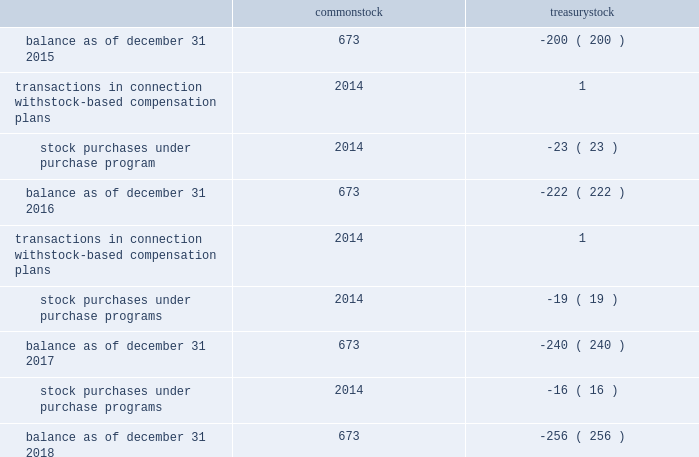Table of contents valero energy corporation notes to consolidated financial statements ( continued ) 11 .
Equity share activity activity in the number of shares of common stock and treasury stock was as follows ( in millions ) : common treasury .
Preferred stock we have 20 million shares of preferred stock authorized with a par value of $ 0.01 per share .
No shares of preferred stock were outstanding as of december 31 , 2018 or 2017 .
Treasury stock we purchase shares of our common stock as authorized under our common stock purchase program ( described below ) and to meet our obligations under employee stock-based compensation plans .
On july 13 , 2015 , our board of directors authorized us to purchase $ 2.5 billion of our outstanding common stock with no expiration date , and we completed that program during 2017 .
On september 21 , 2016 , our board of directors authorized our purchase of up to an additional $ 2.5 billion with no expiration date , and we completed that program during 2018 .
On january 23 , 2018 , our board of directors authorized our purchase of up to an additional $ 2.5 billion ( the 2018 program ) with no expiration date .
During the years ended december 31 , 2018 , 2017 , and 2016 , we purchased $ 1.5 billion , $ 1.3 billion , and $ 1.3 billion , respectively , of our common stock under our programs .
As of december 31 , 2018 , we have approval under the 2018 program to purchase approximately $ 2.2 billion of our common stock .
Common stock dividends on january 24 , 2019 , our board of directors declared a quarterly cash dividend of $ 0.90 per common share payable on march 5 , 2019 to holders of record at the close of business on february 13 , 2019 .
Valero energy partners lp units on september 16 , 2016 , vlp entered into an equity distribution agreement pursuant to which vlp offered and sold from time to time their common units having an aggregate offering price of up to $ 350 million based on amounts , at prices , and on terms determined by market conditions and other factors at the time of .
If the same amount was spent monthly for 24 months purchasing $ 2.5 billion of common stock , what was the monthly average spent be , in billions? 
Computations: (2.5 / 24)
Answer: 0.10417. 